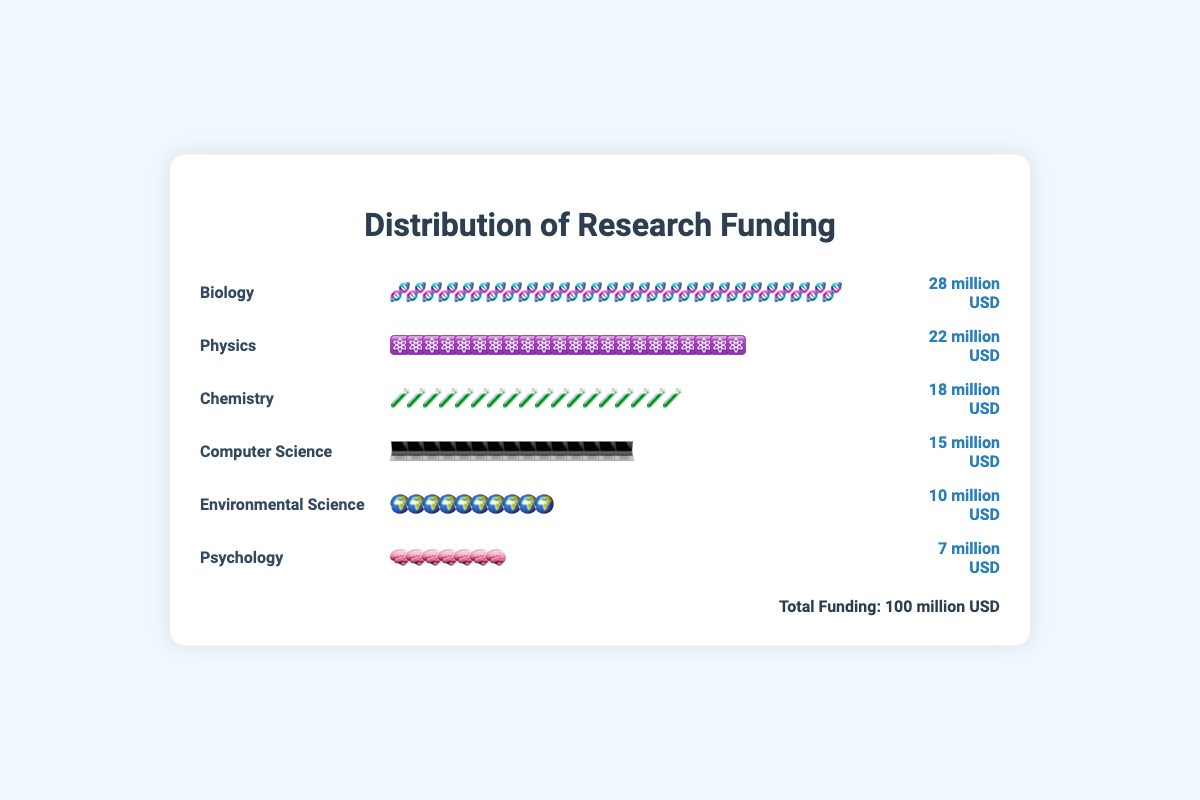What is the total funding allocated to Biology? The plot shows that the funding allocated to Biology is represented by 28 icons, each representing 1 million USD.
Answer: 28 million USD Which discipline has the least amount of funding? By observing the icons associated with each discipline, Psychology has 7 icons, which is the fewest.
Answer: Psychology How much more funding does Biology receive compared to Physics? Biology has 28 million USD in funding, while Physics has 22 million USD. The difference is 28 - 22 = 6 million USD.
Answer: 6 million USD What is the combined funding for Chemistry and Computer Science? Chemistry has 18 million USD and Computer Science has 15 million USD. The total combined funding is 18 + 15 = 33 million USD.
Answer: 33 million USD How many icons are used to represent Computer Science funding? Each icon represents 1 million USD, and the plot has 15 icons for Computer Science.
Answer: 15 icons Which two disciplines combined have the same funding as Biology? Biology has 28 million USD. Physics (22 million USD) and Environmental Science (10 million USD) combined have 22 + 10 = 32 million USD, which is closest but not equal. Chemistry (18 million USD) and Computer Science (15 million USD) combined have 18 + 15 = 33 million USD, which is also not equal. Computer Science (15 million USD) and Environmental Science (10 million USD) combine to 25 million USD, which is not equal. Therefore, there are no two disciplines that exactly combine to equal Biology's funding.
Answer: None What percentage of total funding does Environmental Science receive? Environmental Science has 10 million USD out of a total of 100 million USD. The percentage is (10/100) * 100 = 10%.
Answer: 10% Which discipline receives exactly double the funding of Psychology? Psychology receives 7 million USD. Double of 7 million USD is 14 million USD. No discipline exactly matches this funding.
Answer: None How much funding is allocated to disciplines other than Biology? The total funding for other disciplines is: Physics (22) + Chemistry (18) + Computer Science (15) + Environmental Science (10) + Psychology (7) = 22 + 18 + 15 + 10 + 7 = 72 million USD.
Answer: 72 million USD What is the difference in funding between the highest and lowest funded disciplines? The highest funded discipline is Biology with 28 million USD, and the lowest is Psychology with 7 million USD. The difference is 28 - 7 = 21 million USD.
Answer: 21 million USD 